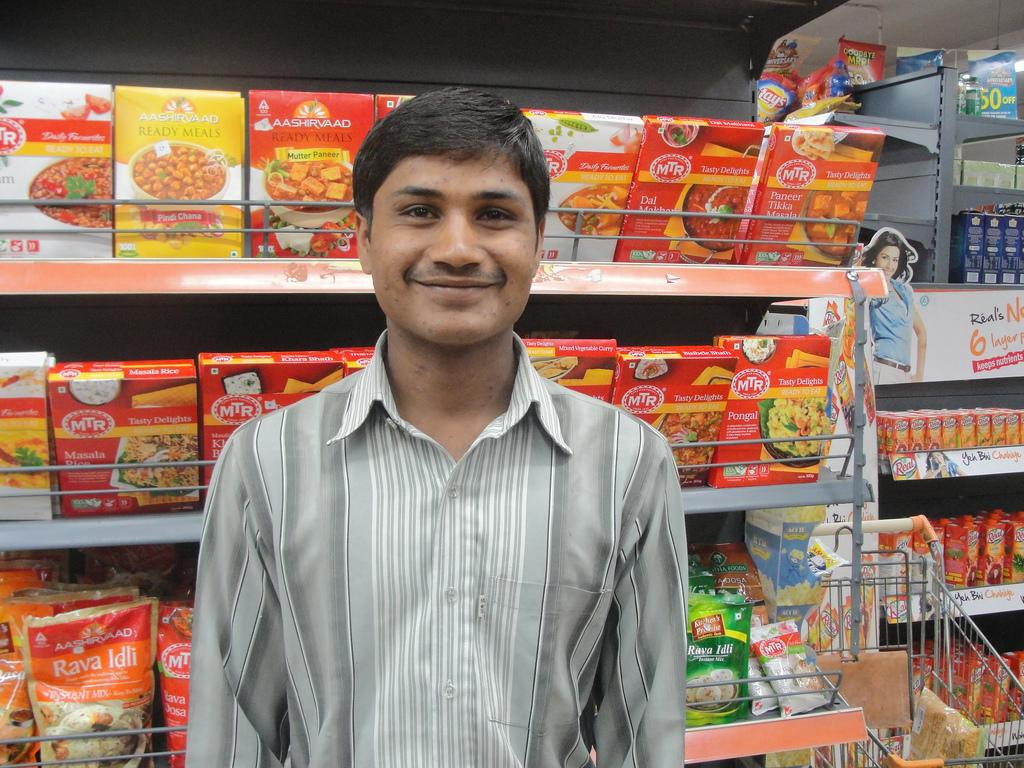What is the main subject of the image? There is a man standing in the center of the image. What can be seen in the background of the image? There are grocery racks and a trolley in the background of the image. How does the man show respect to the grocery racks in the image? There is no indication of the man showing respect to the grocery racks in the image. What fact can be learned about the man's digestion from the image? There is no information about the man's digestion in the image. 